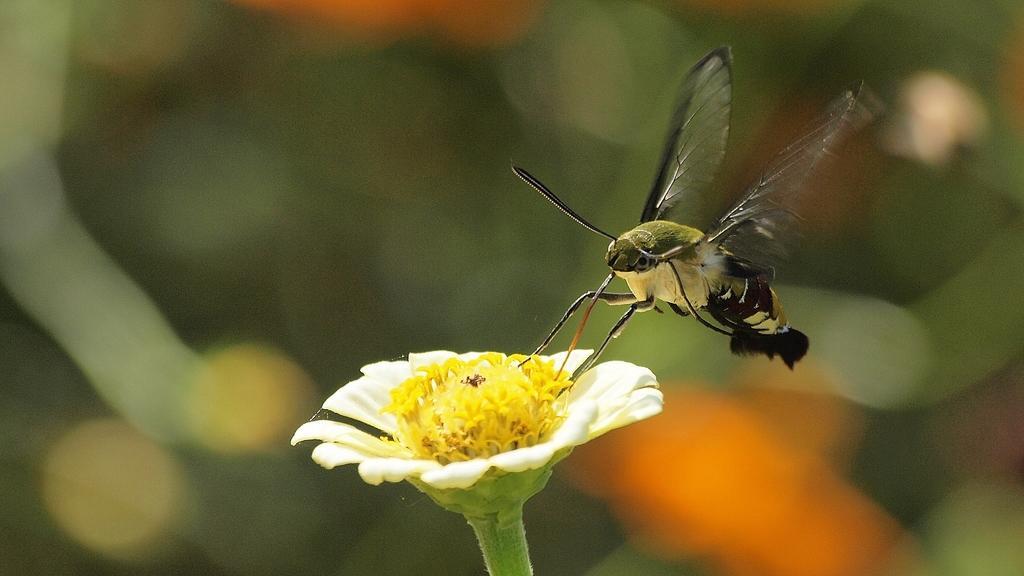Please provide a concise description of this image. In this image, we can see a butterfly sitting on the white color flower and there is a blur background. 